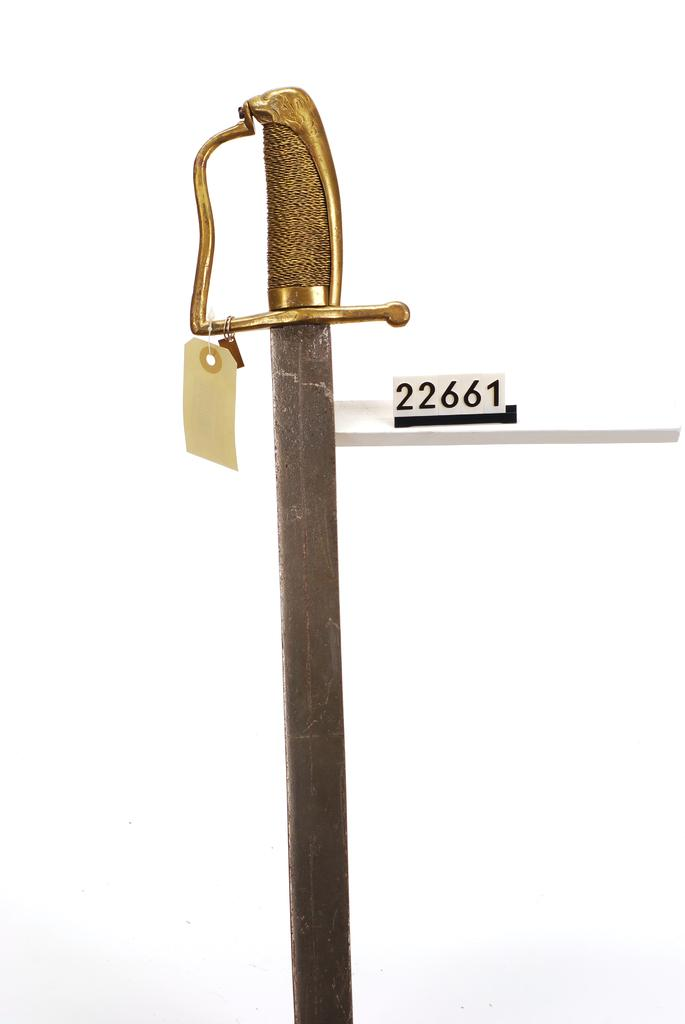What object can be seen in the image that is typically used as a weapon? There is a sword in the image. What other object can be seen in the image? There is a tag in the image. What type of icicle is hanging from the sword in the image? There is no icicle present in the image; it only features a sword and a tag. Where is the bed located in the image? There is no bed present in the image. 